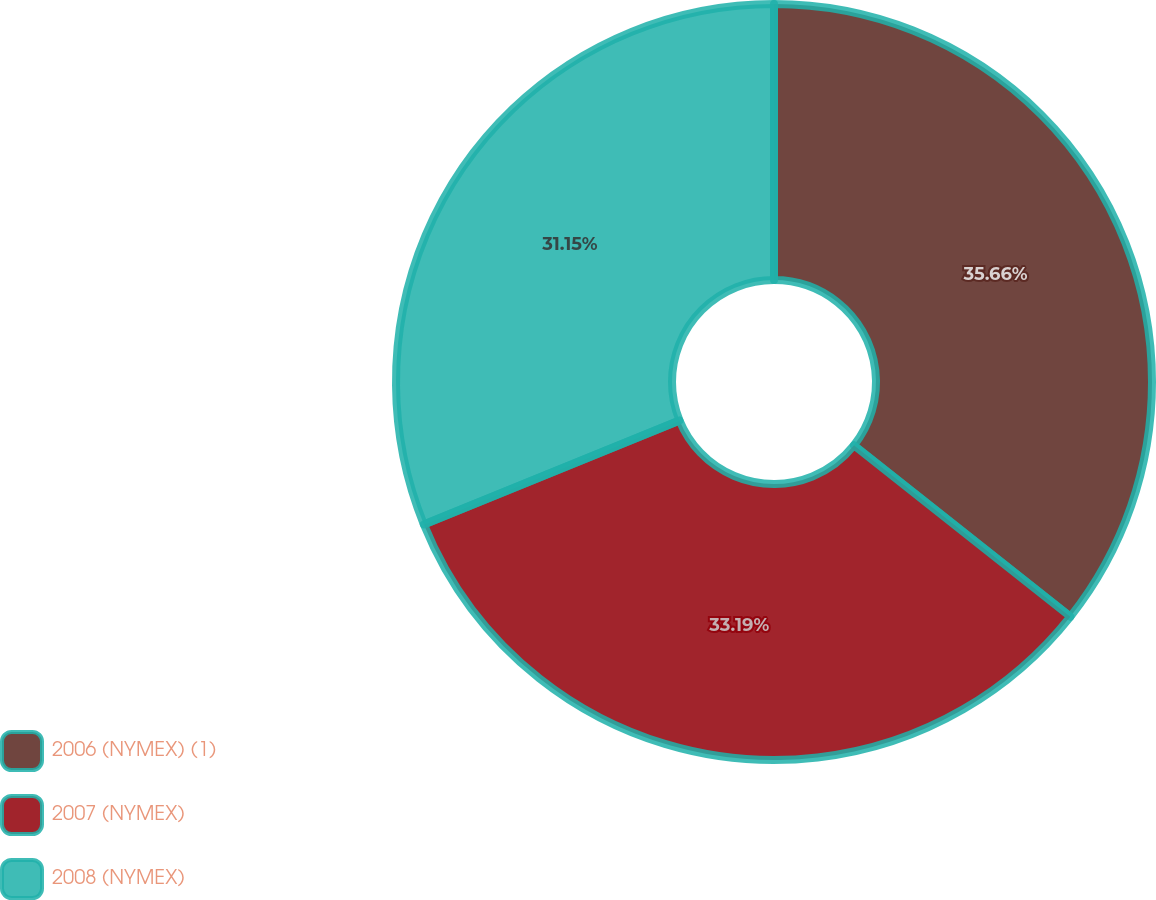<chart> <loc_0><loc_0><loc_500><loc_500><pie_chart><fcel>2006 (NYMEX) (1)<fcel>2007 (NYMEX)<fcel>2008 (NYMEX)<nl><fcel>35.66%<fcel>33.19%<fcel>31.15%<nl></chart> 